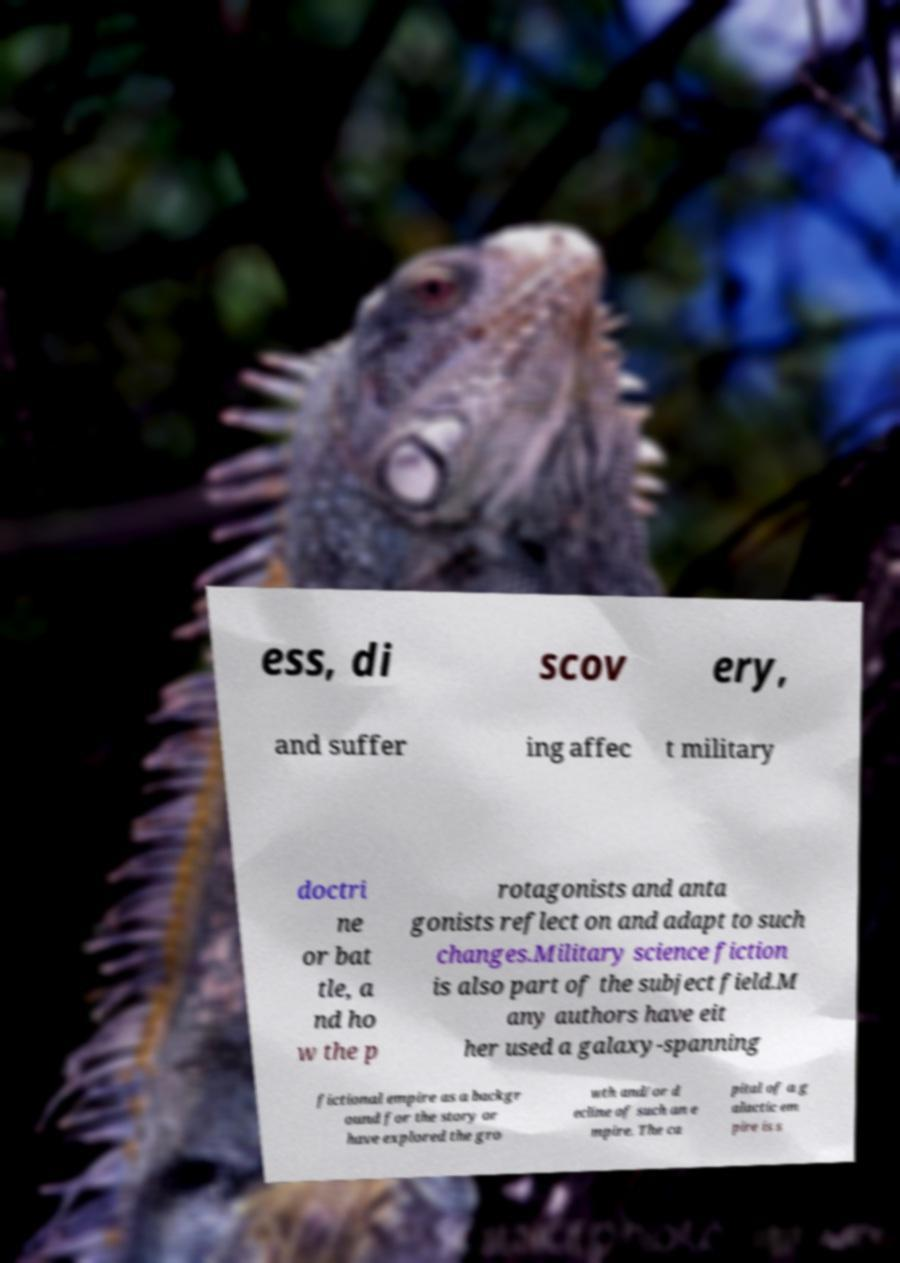For documentation purposes, I need the text within this image transcribed. Could you provide that? ess, di scov ery, and suffer ing affec t military doctri ne or bat tle, a nd ho w the p rotagonists and anta gonists reflect on and adapt to such changes.Military science fiction is also part of the subject field.M any authors have eit her used a galaxy-spanning fictional empire as a backgr ound for the story or have explored the gro wth and/or d ecline of such an e mpire. The ca pital of a g alactic em pire is s 